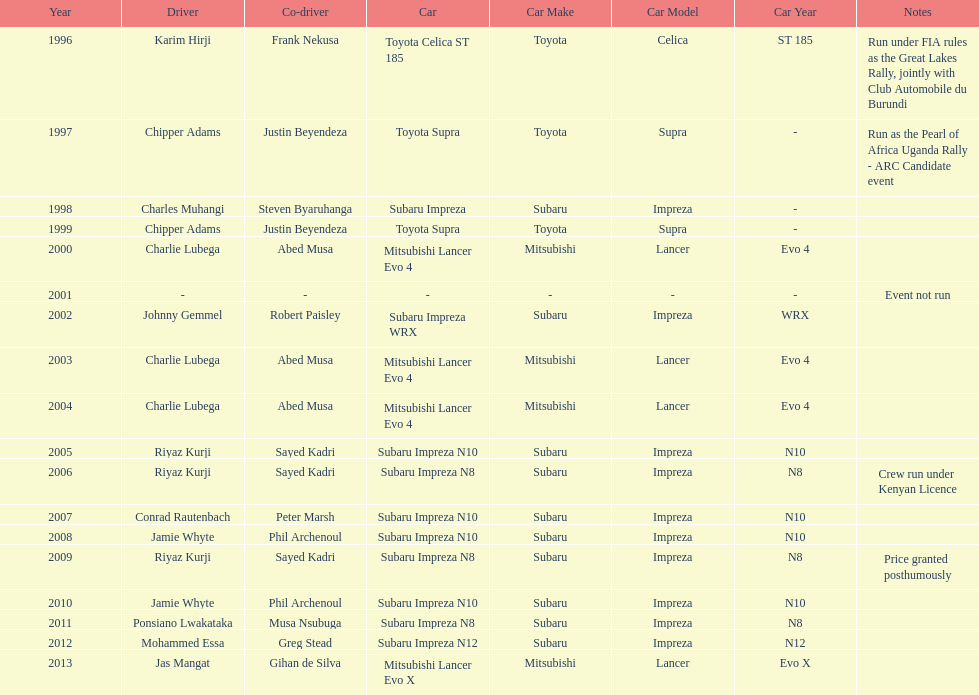Who was the only driver to win in a car other than a subaru impreza after the year 2005? Jas Mangat. Could you help me parse every detail presented in this table? {'header': ['Year', 'Driver', 'Co-driver', 'Car', 'Car Make', 'Car Model', 'Car Year', 'Notes'], 'rows': [['1996', 'Karim Hirji', 'Frank Nekusa', 'Toyota Celica ST 185', 'Toyota', 'Celica', 'ST 185', 'Run under FIA rules as the Great Lakes Rally, jointly with Club Automobile du Burundi'], ['1997', 'Chipper Adams', 'Justin Beyendeza', 'Toyota Supra', 'Toyota', 'Supra', '-', 'Run as the Pearl of Africa Uganda Rally - ARC Candidate event'], ['1998', 'Charles Muhangi', 'Steven Byaruhanga', 'Subaru Impreza', 'Subaru', 'Impreza', '-', ''], ['1999', 'Chipper Adams', 'Justin Beyendeza', 'Toyota Supra', 'Toyota', 'Supra', '-', ''], ['2000', 'Charlie Lubega', 'Abed Musa', 'Mitsubishi Lancer Evo 4', 'Mitsubishi', 'Lancer', 'Evo 4', ''], ['2001', '-', '-', '-', '-', '-', '-', 'Event not run'], ['2002', 'Johnny Gemmel', 'Robert Paisley', 'Subaru Impreza WRX', 'Subaru', 'Impreza', 'WRX', ''], ['2003', 'Charlie Lubega', 'Abed Musa', 'Mitsubishi Lancer Evo 4', 'Mitsubishi', 'Lancer', 'Evo 4', ''], ['2004', 'Charlie Lubega', 'Abed Musa', 'Mitsubishi Lancer Evo 4', 'Mitsubishi', 'Lancer', 'Evo 4', ''], ['2005', 'Riyaz Kurji', 'Sayed Kadri', 'Subaru Impreza N10', 'Subaru', 'Impreza', 'N10', ''], ['2006', 'Riyaz Kurji', 'Sayed Kadri', 'Subaru Impreza N8', 'Subaru', 'Impreza', 'N8', 'Crew run under Kenyan Licence'], ['2007', 'Conrad Rautenbach', 'Peter Marsh', 'Subaru Impreza N10', 'Subaru', 'Impreza', 'N10', ''], ['2008', 'Jamie Whyte', 'Phil Archenoul', 'Subaru Impreza N10', 'Subaru', 'Impreza', 'N10', ''], ['2009', 'Riyaz Kurji', 'Sayed Kadri', 'Subaru Impreza N8', 'Subaru', 'Impreza', 'N8', 'Price granted posthumously'], ['2010', 'Jamie Whyte', 'Phil Archenoul', 'Subaru Impreza N10', 'Subaru', 'Impreza', 'N10', ''], ['2011', 'Ponsiano Lwakataka', 'Musa Nsubuga', 'Subaru Impreza N8', 'Subaru', 'Impreza', 'N8', ''], ['2012', 'Mohammed Essa', 'Greg Stead', 'Subaru Impreza N12', 'Subaru', 'Impreza', 'N12', ''], ['2013', 'Jas Mangat', 'Gihan de Silva', 'Mitsubishi Lancer Evo X', 'Mitsubishi', 'Lancer', 'Evo X', '']]} 